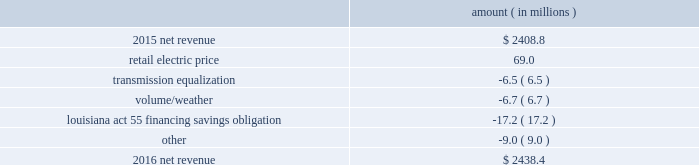Entergy louisiana , llc and subsidiaries management 2019s financial discussion and analysis results of operations net income 2016 compared to 2015 net income increased $ 175.4 million primarily due to the effect of a settlement with the irs related to the 2010-2011 irs audit , which resulted in a $ 136.1 million reduction of income tax expense .
Also contributing to the increase were lower other operation and maintenance expenses , higher net revenue , and higher other income .
The increase was partially offset by higher depreciation and amortization expenses , higher interest expense , and higher nuclear refueling outage expenses .
2015 compared to 2014 net income increased slightly , by $ 0.6 million , primarily due to higher net revenue and a lower effective income tax rate , offset by higher other operation and maintenance expenses , higher depreciation and amortization expenses , lower other income , and higher interest expense .
Net revenue 2016 compared to 2015 net revenue consists of operating revenues net of : 1 ) fuel , fuel-related expenses , and gas purchased for resale , 2 ) purchased power expenses , and 3 ) other regulatory charges .
Following is an analysis of the change in net revenue comparing 2016 to 2015 .
Amount ( in millions ) .
The retail electric price variance is primarily due to an increase in formula rate plan revenues , implemented with the first billing cycle of march 2016 , to collect the estimated first-year revenue requirement related to the purchase of power blocks 3 and 4 of the union power station .
See note 2 to the financial statements for further discussion .
The transmission equalization variance is primarily due to changes in transmission investments , including entergy louisiana 2019s exit from the system agreement in august 2016 .
The volume/weather variance is primarily due to the effect of less favorable weather on residential sales , partially offset by an increase in industrial usage and an increase in volume during the unbilled period .
The increase .
What is the growth rate in net revenue in 2016 for entergy louisiana? 
Computations: ((2438.4 - 2408.8) / 2408.8)
Answer: 0.01229. 